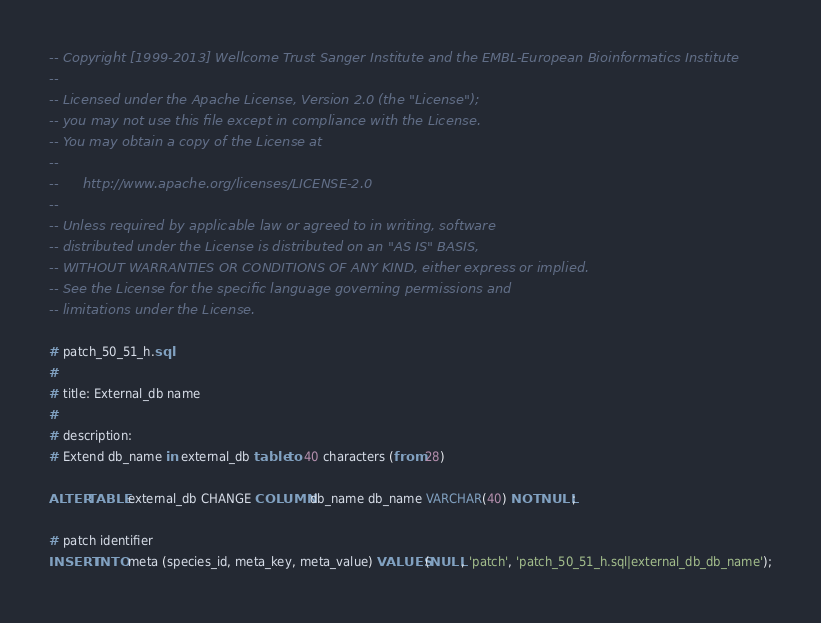<code> <loc_0><loc_0><loc_500><loc_500><_SQL_>-- Copyright [1999-2013] Wellcome Trust Sanger Institute and the EMBL-European Bioinformatics Institute
-- 
-- Licensed under the Apache License, Version 2.0 (the "License");
-- you may not use this file except in compliance with the License.
-- You may obtain a copy of the License at
-- 
--      http://www.apache.org/licenses/LICENSE-2.0
-- 
-- Unless required by applicable law or agreed to in writing, software
-- distributed under the License is distributed on an "AS IS" BASIS,
-- WITHOUT WARRANTIES OR CONDITIONS OF ANY KIND, either express or implied.
-- See the License for the specific language governing permissions and
-- limitations under the License.

# patch_50_51_h.sql
#
# title: External_db name
#
# description:
# Extend db_name in external_db table to 40 characters (from 28)

ALTER TABLE external_db CHANGE COLUMN db_name db_name VARCHAR(40) NOT NULL;

# patch identifier
INSERT INTO meta (species_id, meta_key, meta_value) VALUES (NULL, 'patch', 'patch_50_51_h.sql|external_db_db_name');


</code> 